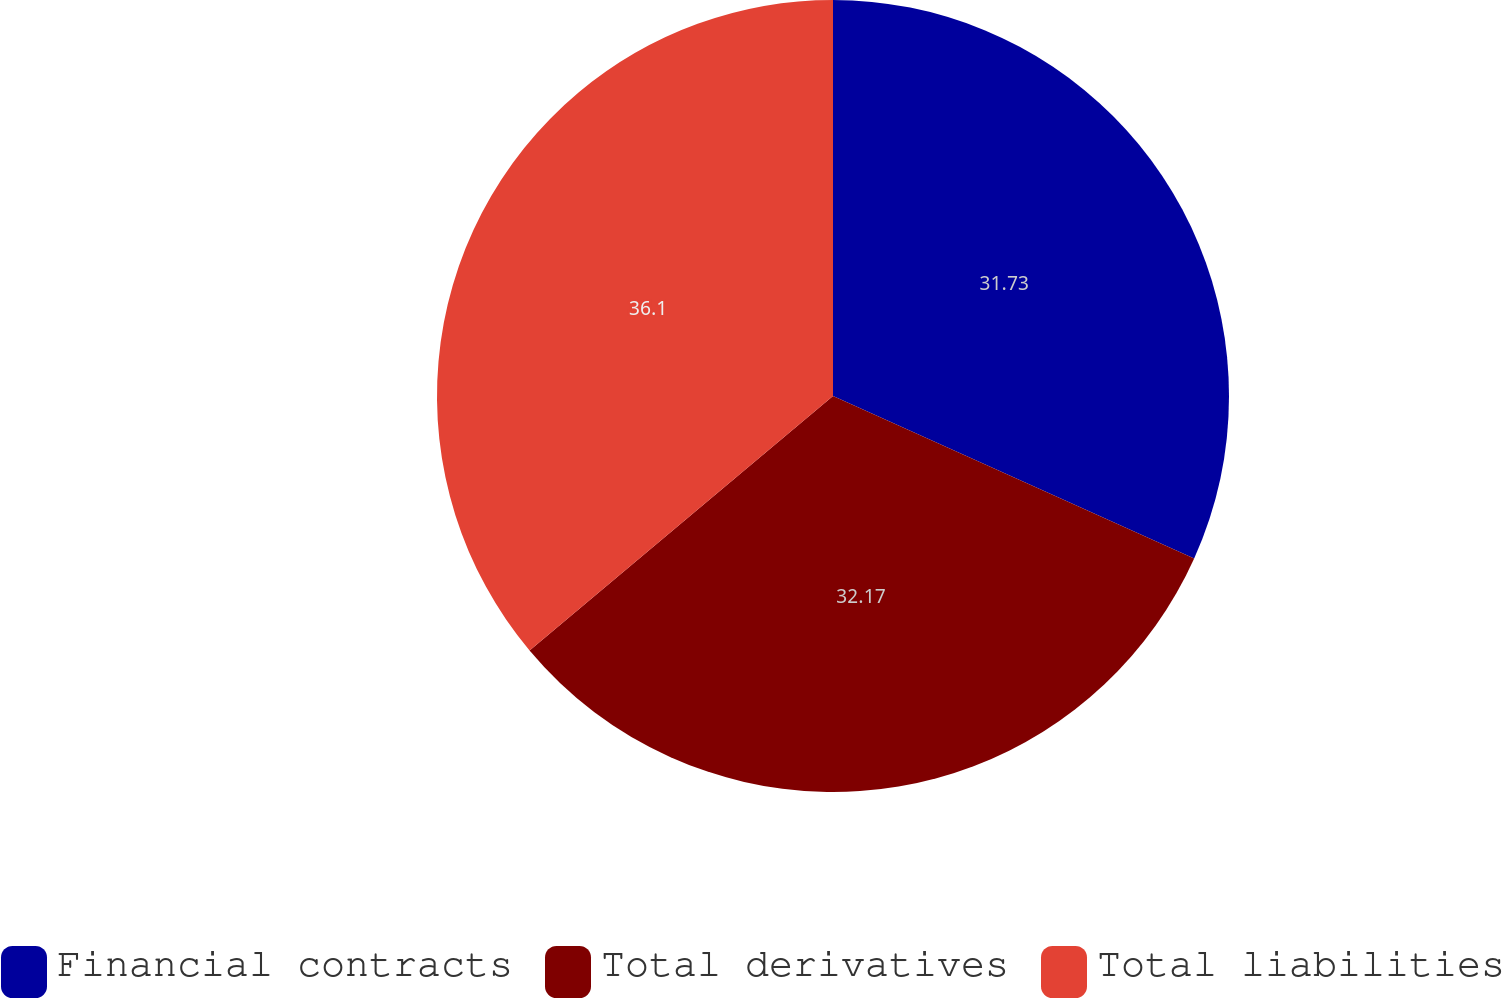<chart> <loc_0><loc_0><loc_500><loc_500><pie_chart><fcel>Financial contracts<fcel>Total derivatives<fcel>Total liabilities<nl><fcel>31.73%<fcel>32.17%<fcel>36.11%<nl></chart> 